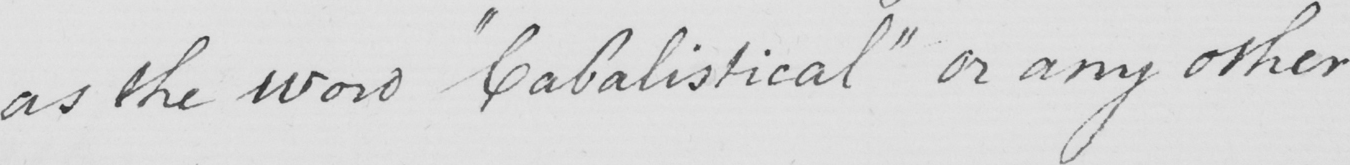Please transcribe the handwritten text in this image. as the word  " Cabalistical "  or any other 